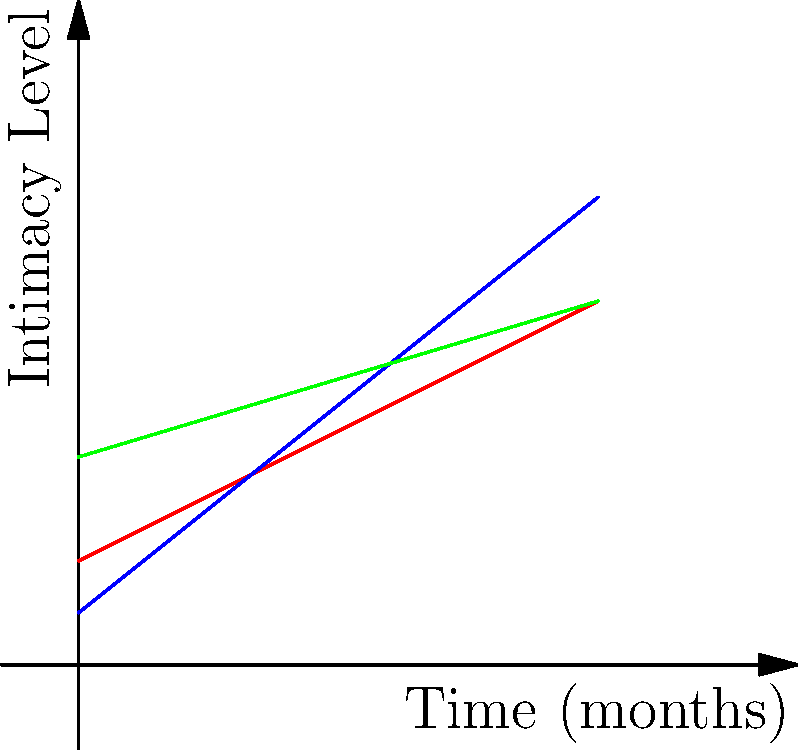Based on the line graph depicting the progression of intimacy in relationships over time for three couples, which couple shows the most rapid increase in intimacy, and what might this suggest about their relationship dynamics? To answer this question, we need to analyze the slopes of the lines representing each couple:

1. Couple A (red line): The line has a moderate positive slope.
2. Couple B (blue line): This line has the steepest positive slope among the three.
3. Couple C (green line): The line has a gentle positive slope.

The slope of each line represents the rate of change in intimacy over time. A steeper slope indicates a more rapid increase in intimacy.

Couple B's line has the steepest slope, indicating the fastest rate of intimacy progression. This suggests that:

1. Couple B is experiencing the most rapid increase in emotional closeness, trust, and vulnerability.
2. They may be in the "honeymoon phase" of their relationship, characterized by intense feelings and rapid bonding.
3. Their relationship might be moving quickly, which could indicate strong compatibility or potentially rushed emotional involvement.
4. They may need guidance on pacing their relationship to ensure a sustainable long-term connection.

As a psychologist specializing in interpersonal relationships, it's important to note that while rapid intimacy progression can be exciting, it may also present challenges. Couples experiencing such rapid intimacy growth might benefit from discussions about expectations, boundaries, and long-term relationship goals.
Answer: Couple B shows the most rapid increase in intimacy, suggesting an intense "honeymoon phase" that may require careful navigation for long-term sustainability. 